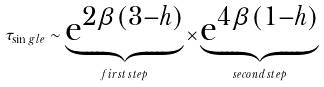Convert formula to latex. <formula><loc_0><loc_0><loc_500><loc_500>\tau _ { \sin g l e } \sim \underbrace { { \mathrm e } ^ { 2 \beta ( 3 - h ) } } _ { f i r s t \, s t e p } \times \underbrace { { \mathrm e } ^ { 4 \beta ( 1 - h ) } } _ { s e c o n d \, s t e p }</formula> 